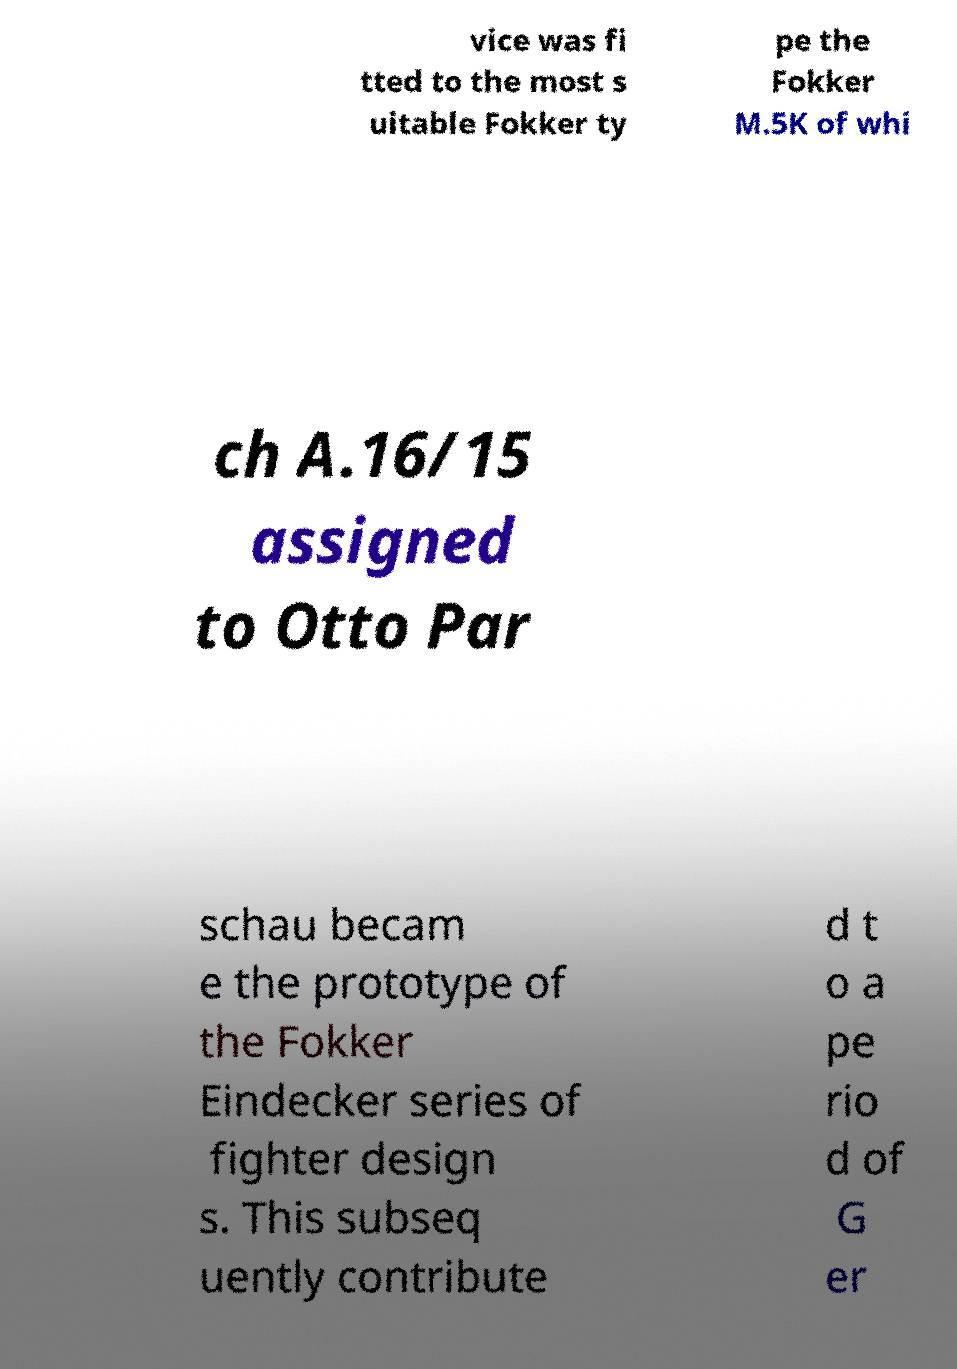Please identify and transcribe the text found in this image. vice was fi tted to the most s uitable Fokker ty pe the Fokker M.5K of whi ch A.16/15 assigned to Otto Par schau becam e the prototype of the Fokker Eindecker series of fighter design s. This subseq uently contribute d t o a pe rio d of G er 